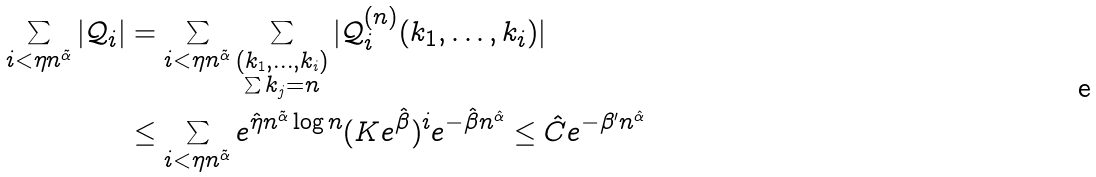<formula> <loc_0><loc_0><loc_500><loc_500>\sum _ { i < \eta n ^ { \tilde { \alpha } } } | \mathcal { Q } _ { i } | & = \sum _ { i < \eta n ^ { \tilde { \alpha } } } \sum _ { \substack { ( k _ { 1 } , \dots , k _ { i } ) \\ \sum k _ { j } = n } } | \mathcal { Q } ^ { ( n ) } _ { i } ( k _ { 1 } , \dots , k _ { i } ) | \\ & \leq \sum _ { i < \eta n ^ { \tilde { \alpha } } } e ^ { \hat { \eta } n ^ { \tilde { \alpha } } \log n } ( K e ^ { \hat { \beta } } ) ^ { i } e ^ { - \hat { \beta } n ^ { \hat { \alpha } } } \leq \hat { C } e ^ { - \beta ^ { \prime } n ^ { \hat { \alpha } } }</formula> 